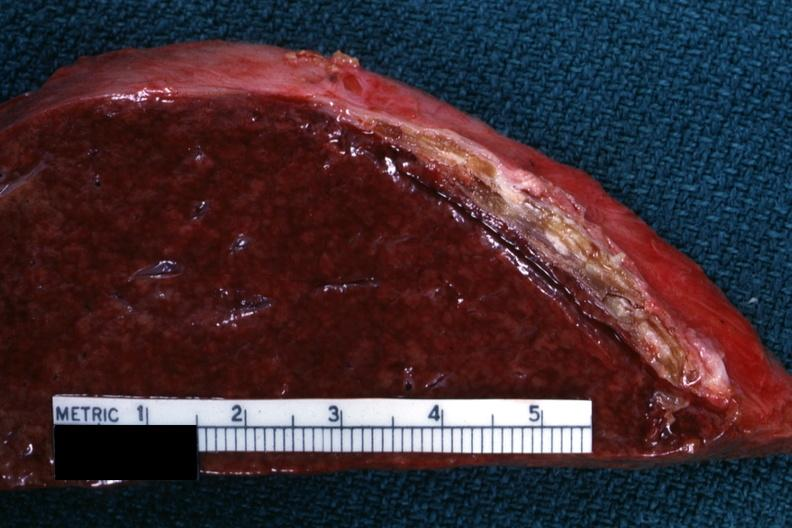where is this part in?
Answer the question using a single word or phrase. Spleen 